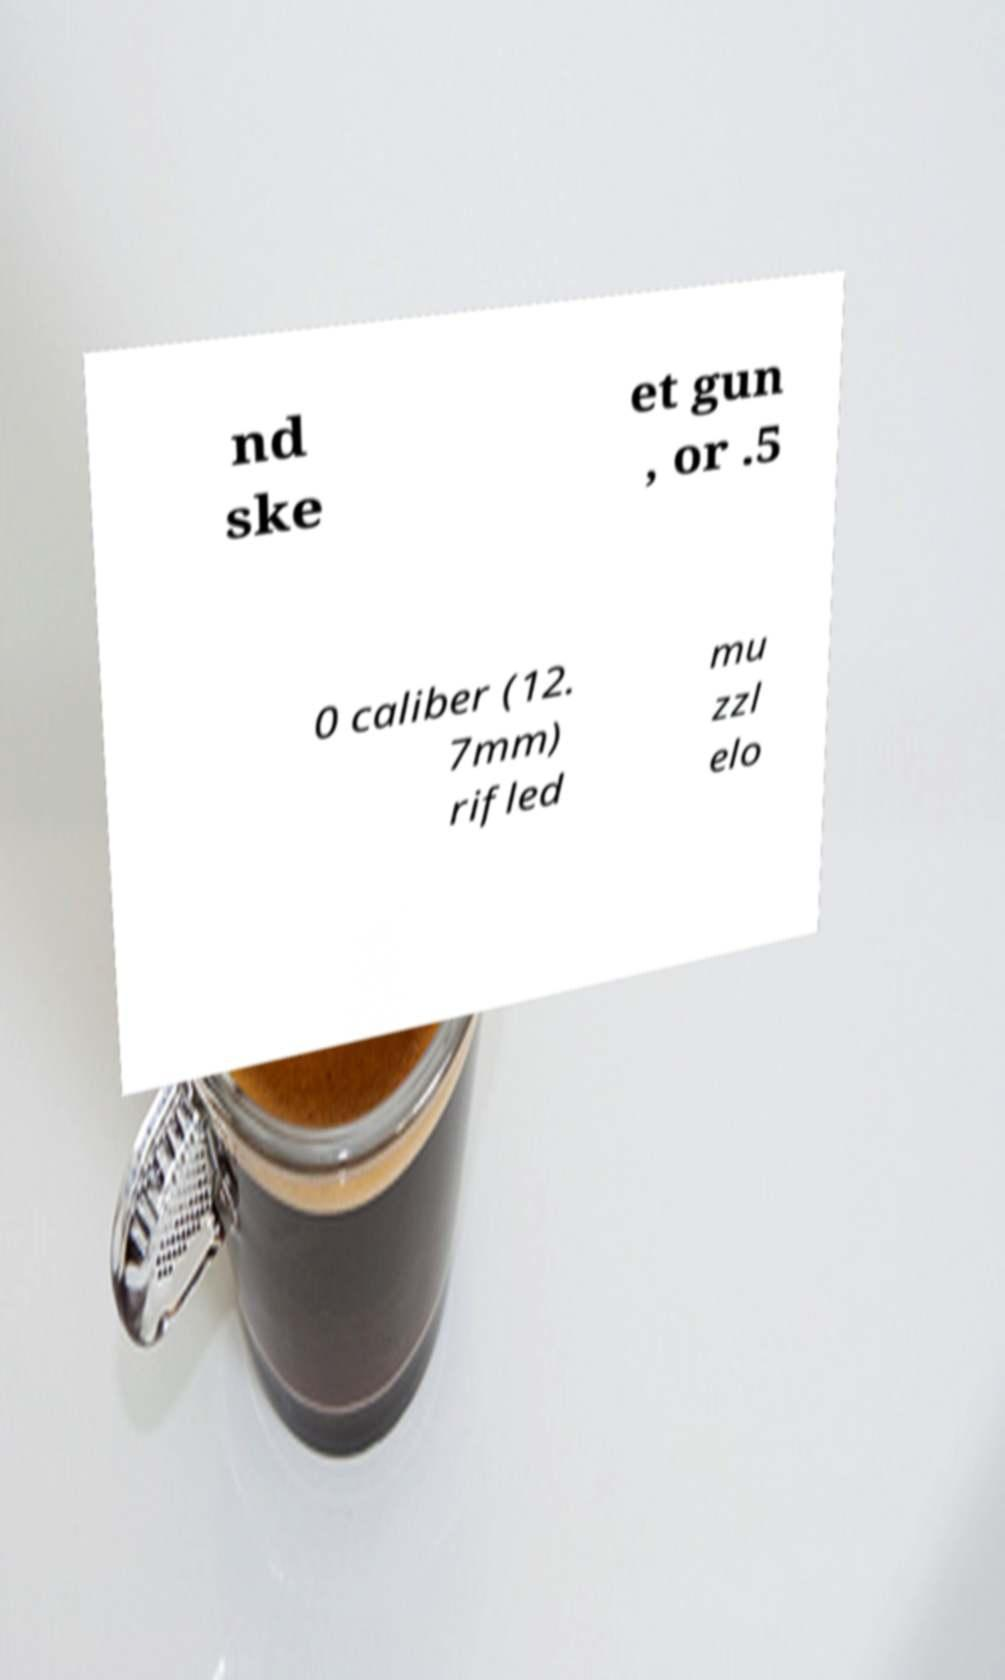For documentation purposes, I need the text within this image transcribed. Could you provide that? nd ske et gun , or .5 0 caliber (12. 7mm) rifled mu zzl elo 